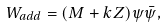Convert formula to latex. <formula><loc_0><loc_0><loc_500><loc_500>W _ { a d d } = ( M + k Z ) \psi { \bar { \psi } } ,</formula> 